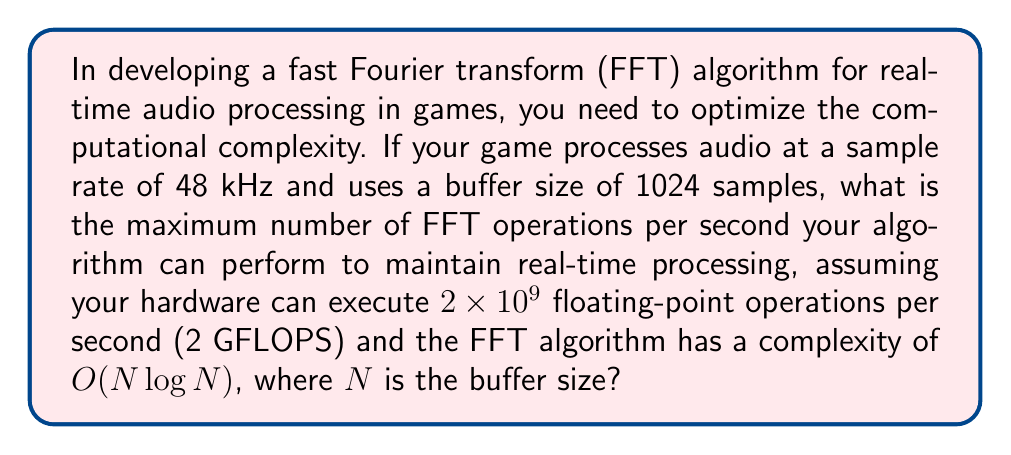Can you answer this question? To solve this problem, we need to follow these steps:

1. Calculate the number of FFT operations needed per second:
   - Sample rate = 48 kHz = 48,000 samples/second
   - Buffer size = 1024 samples
   - FFT operations per second = 48,000 / 1024 = 46.875 FFTs/second

2. Calculate the number of floating-point operations for one FFT:
   - FFT complexity = $O(N \log N)$
   - $N = 1024$
   - Floating-point operations per FFT ≈ $1024 \log_2(1024) = 1024 \times 10 = 10,240$

3. Calculate total floating-point operations per second:
   - Total FLOPS = FFTs/second × FLOPS/FFT
   - Total FLOPS = 46.875 × 10,240 = 480,000 FLOPS

4. Compare with hardware capability:
   - Hardware capability = 2 GFLOPS = $2 \times 10^9$ FLOPS
   - Maximum FFTs/second = $\frac{2 \times 10^9}{10,240} \approx 195,312.5$

Therefore, the maximum number of FFT operations per second that can be performed while maintaining real-time processing is the floor of 195,312.5, which is 195,312.
Answer: 195,312 FFT operations per second 